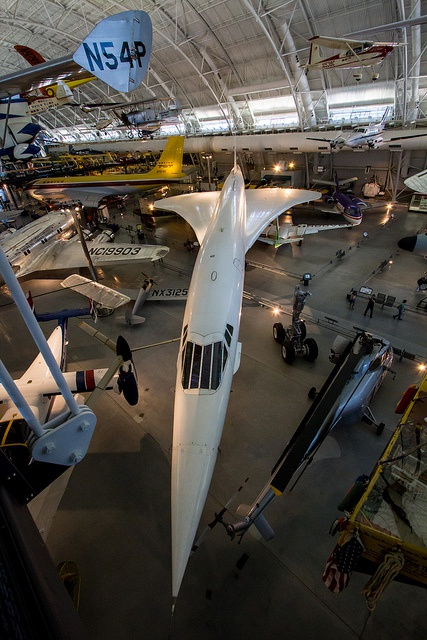Describe the objects in this image and their specific colors. I can see airplane in darkgray, gray, and black tones, airplane in darkgray, black, gray, and blue tones, airplane in darkgray, black, gray, and tan tones, airplane in darkgray and gray tones, and airplane in darkgray, black, gray, and olive tones in this image. 